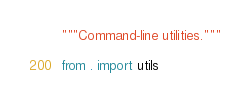<code> <loc_0><loc_0><loc_500><loc_500><_Python_>"""Command-line utilities."""

from . import utils
</code> 